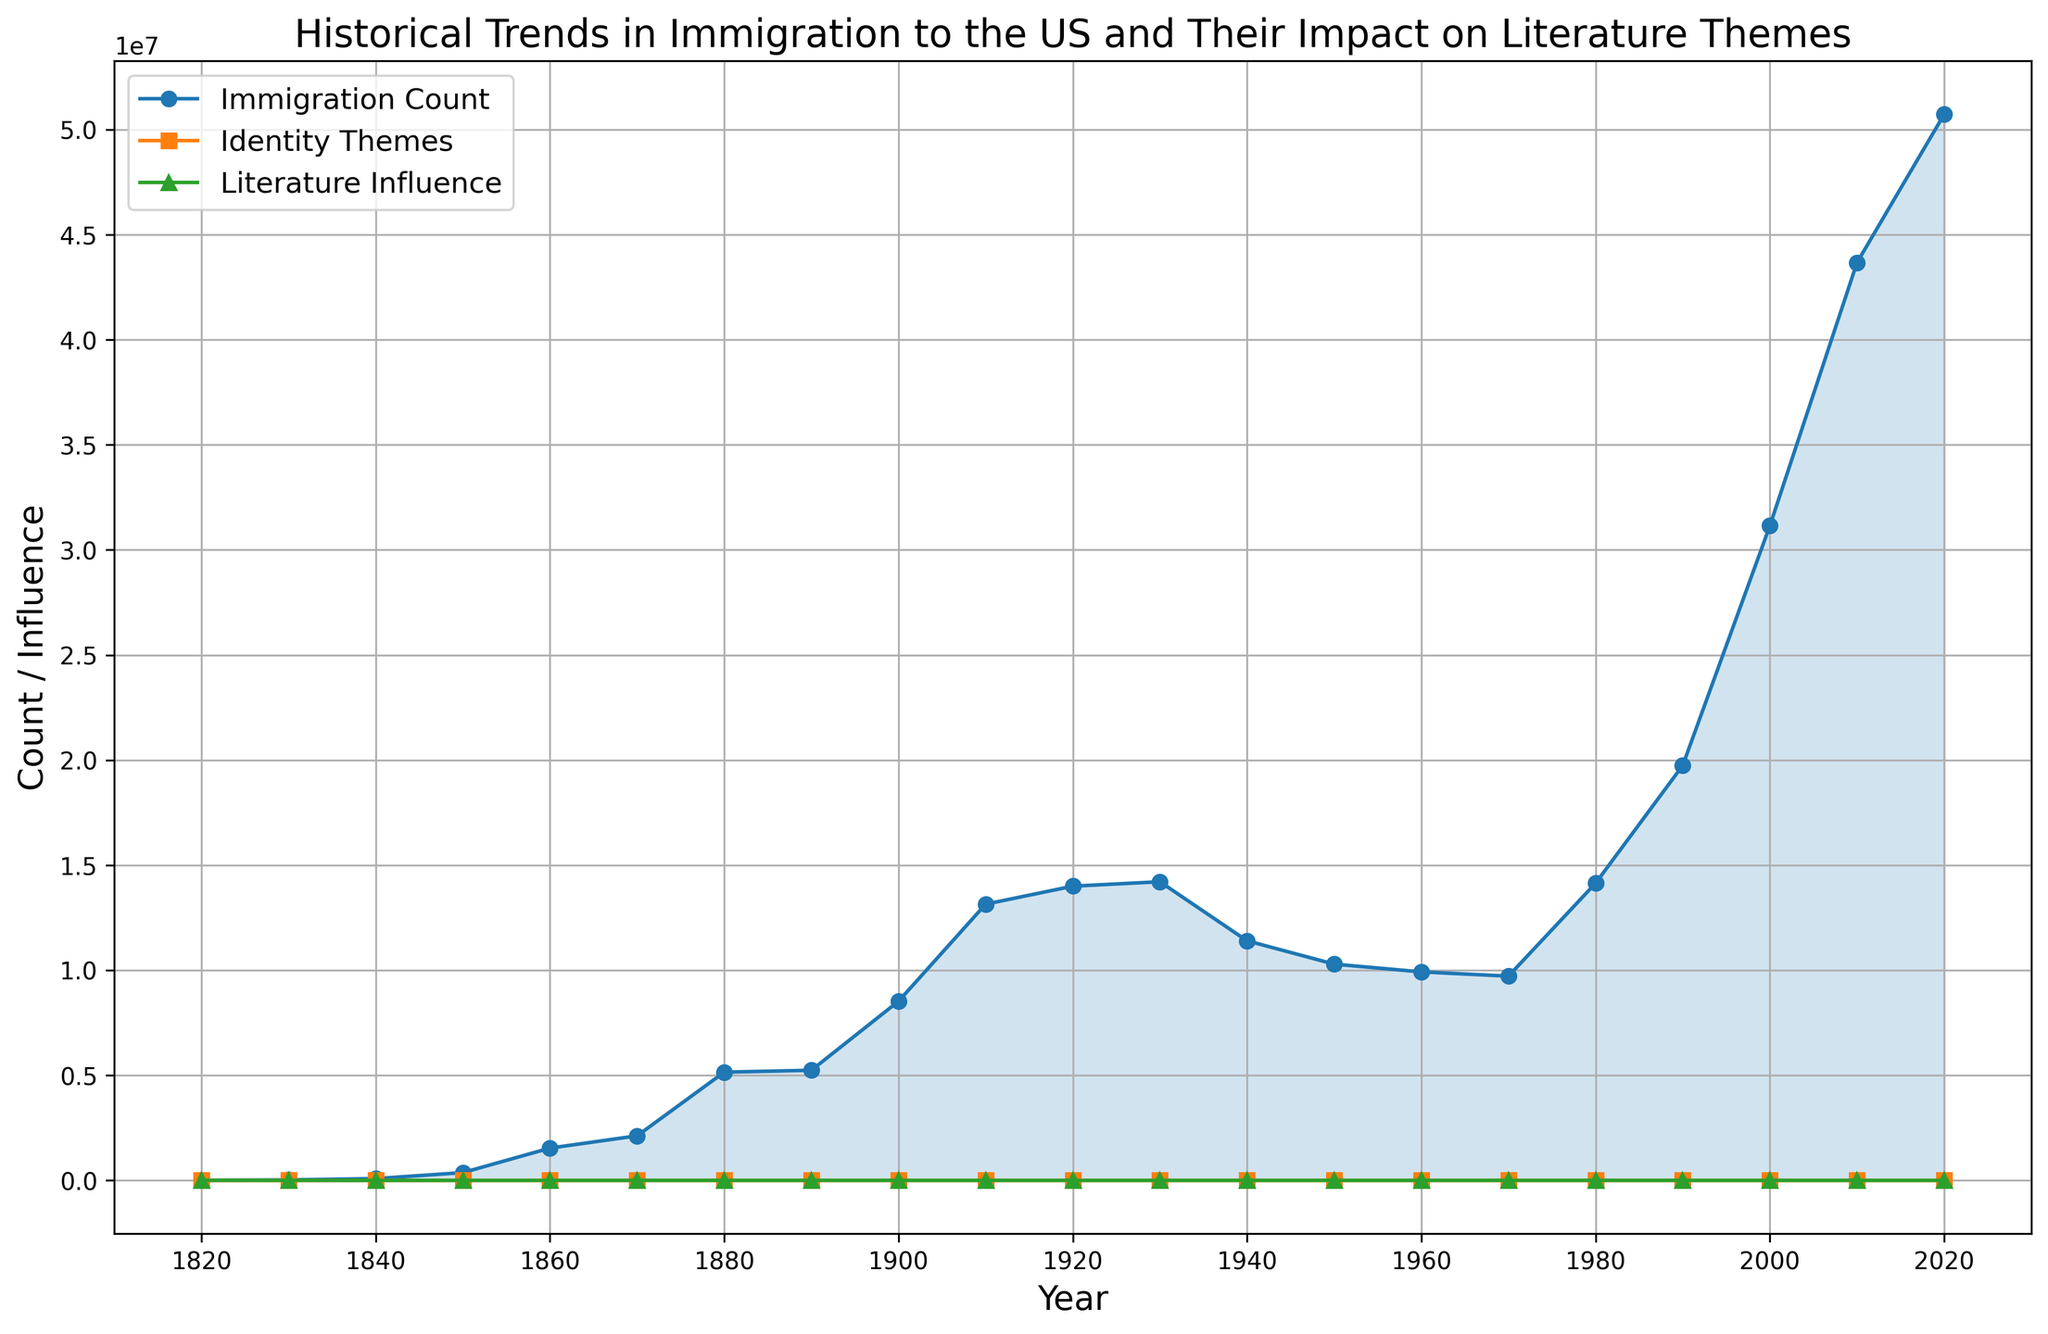What is the overall trend in immigration count from 1820 to 2020? The trend shows a significant increase in the number of immigrants to the US over time, with the count rising from 8,385 in 1820 to 50,722,000 in 2020. This suggests sustained growth in immigration through the years.
Answer: Increasing trend How do the themes of identity compare to the immigration count in 1900? In 1900, the immigration count is 8,524,000, and the identity themes value is 60. The graph shows that while immigration numbers are high, the value for identity themes is relatively lower, indicating that these themes are perhaps starting to emerge strongly in literature but not at their peak.
Answer: Immigration count is higher What year did the literature influence reach a value of 200? By looking at the literature influence line (green) and its intersection with the value of 200, it happens in the year 1970.
Answer: 1970 Between which decades did the largest increase in immigration count occur? By visually inspecting the steepest rise in the blue line (immigration count), we see the largest increase happened between 2000 and 2010, where the count jumped from 31,146,000 to 43,668,000.
Answer: Between 2000 and 2010 Compare the value of literature influence in 1850 and 1950. In 1850, the literature influence value is 60, while in 1950, it is 180 according to the green line. The value in 1950 is three times higher than in 1850.
Answer: 180 in 1950 and 60 in 1850 How much did the identity themes value increase from 1960 to 2020? In 1960, the identity themes value is 90 and in 2020 it is 135. The increase is calculated as 135 - 90 = 45.
Answer: Increase by 45 Which period saw a noticeable dip in immigration count and what might be associated with this dip? The only noticeable dip in the blue line occurred between 1930 and 1950, which can be associated with the Great Depression and World War II, leading to fewer immigrants entering the US.
Answer: 1930 to 1950 How does the trend in identity themes correlate with the immigration count from 1940 onwards? Post-1940, both immigration count (blue) and identity themes (orange) show an overall increasing trend. This indicates a correlation where rising immigration count seems to accompany a rise in identity themes in literature.
Answer: Both increase What is the difference in the literature influence values between the years 1930 and 1940? In 1930, the literature influence value is 165, and in 1940 it is 170. The difference is 170 - 165 = 5.
Answer: Difference of 5 In which year did the identity themes line surpass the value of 100, and what was the immigration count at this point? The identity themes line (orange) surpassed the value of 100 in the year 1980. At this point, the immigration count (blue) was 14,140,000.
Answer: 1980, 14,140,000 